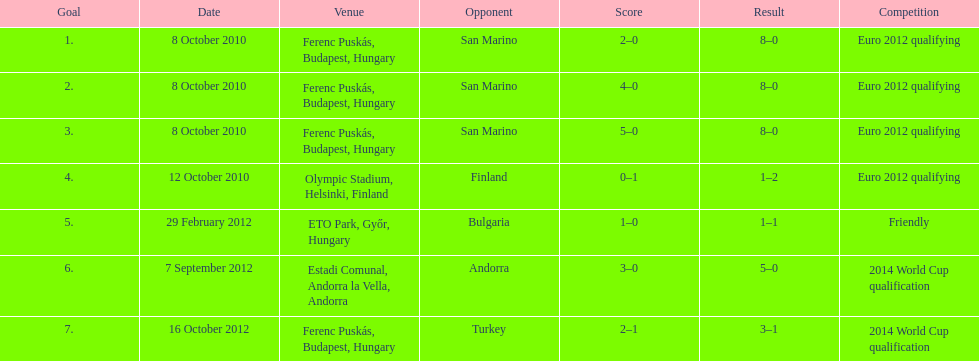In what year did ádám szalai make his next international goal after 2010? 2012. 